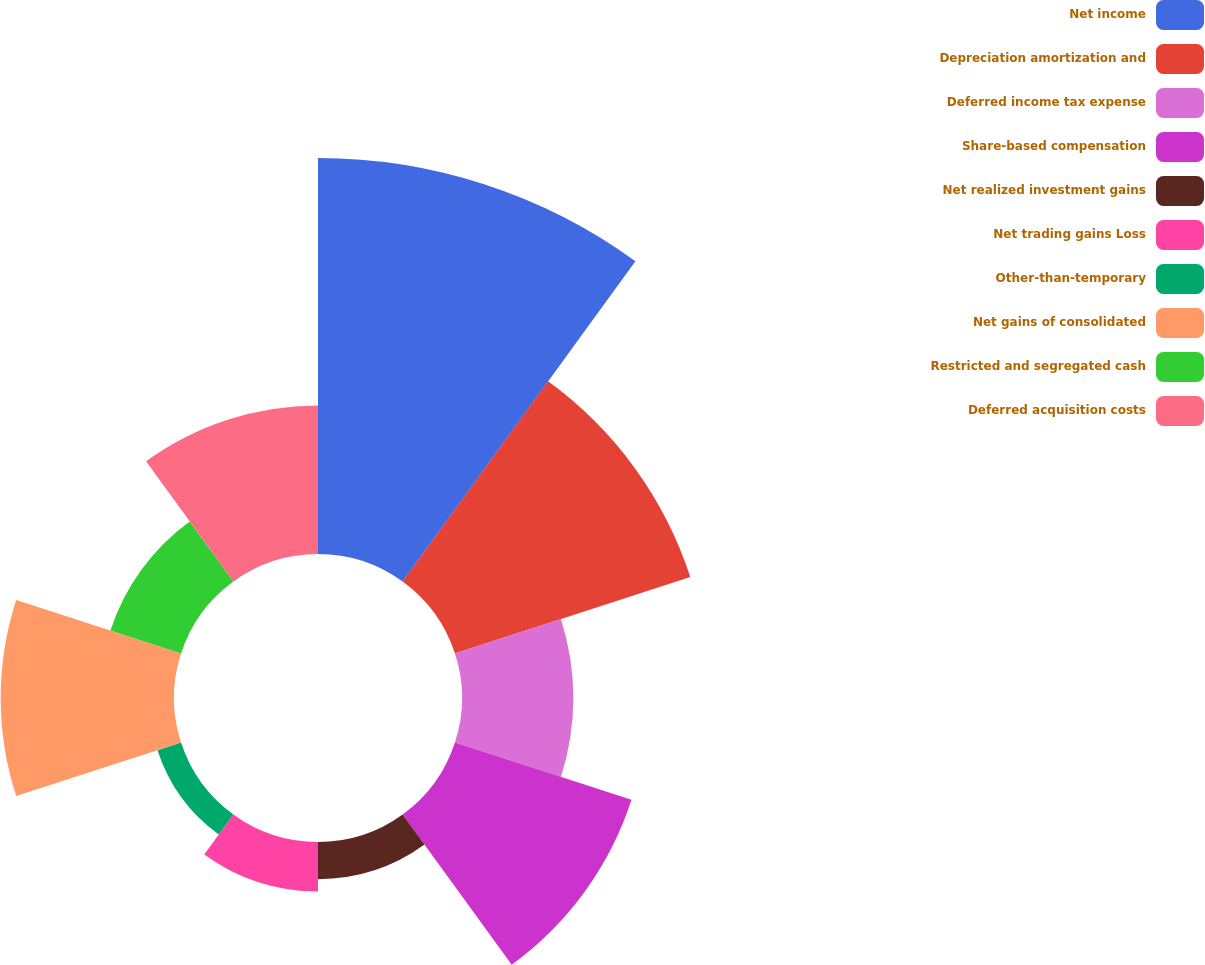Convert chart. <chart><loc_0><loc_0><loc_500><loc_500><pie_chart><fcel>Net income<fcel>Depreciation amortization and<fcel>Deferred income tax expense<fcel>Share-based compensation<fcel>Net realized investment gains<fcel>Net trading gains Loss<fcel>Other-than-temporary<fcel>Net gains of consolidated<fcel>Restricted and segregated cash<fcel>Deferred acquisition costs<nl><fcel>27.35%<fcel>17.09%<fcel>7.69%<fcel>12.82%<fcel>2.57%<fcel>3.42%<fcel>1.71%<fcel>11.97%<fcel>5.13%<fcel>10.26%<nl></chart> 